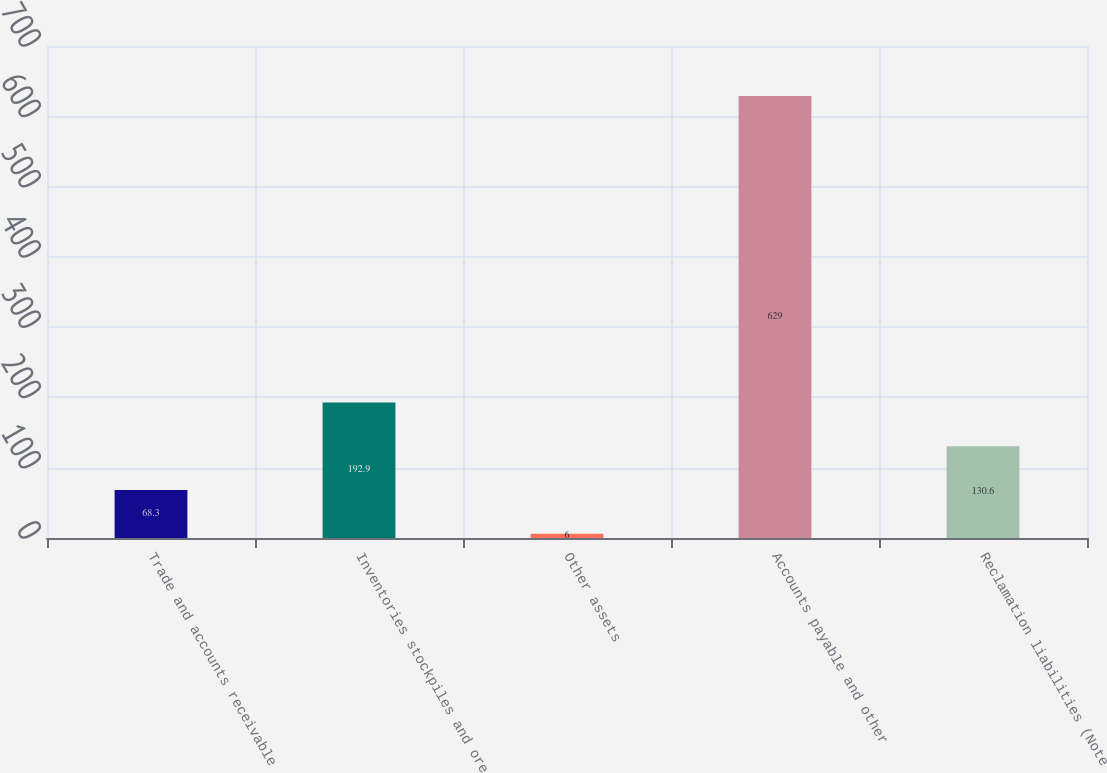Convert chart. <chart><loc_0><loc_0><loc_500><loc_500><bar_chart><fcel>Trade and accounts receivable<fcel>Inventories stockpiles and ore<fcel>Other assets<fcel>Accounts payable and other<fcel>Reclamation liabilities (Note<nl><fcel>68.3<fcel>192.9<fcel>6<fcel>629<fcel>130.6<nl></chart> 